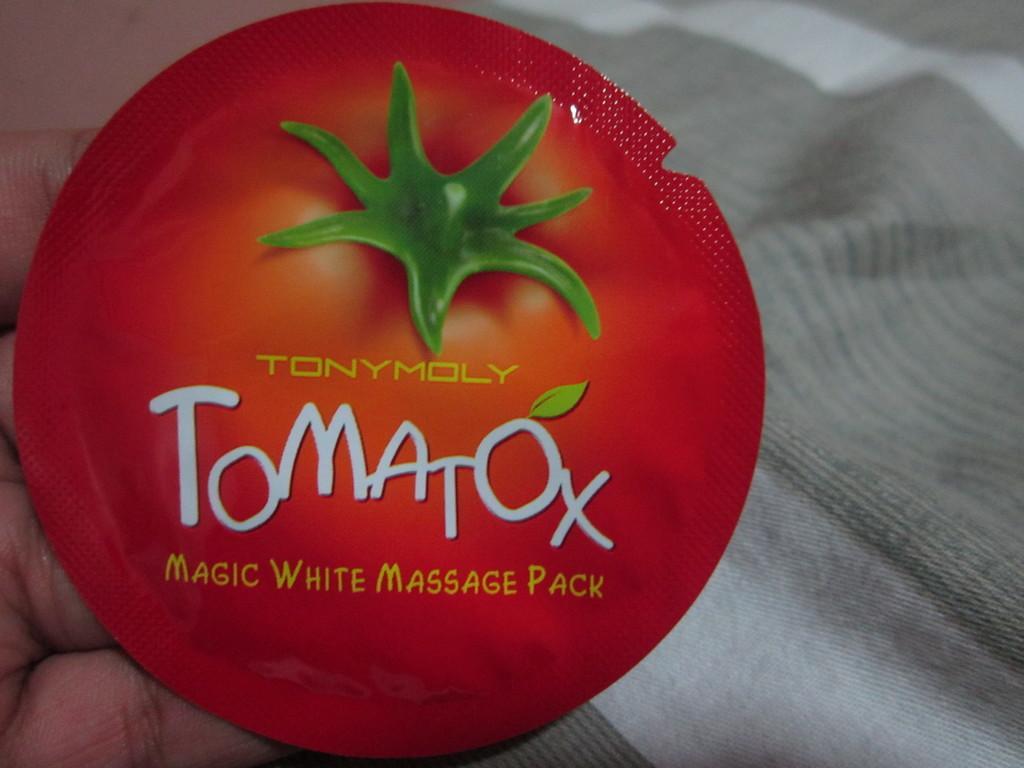Describe this image in one or two sentences. In the picture I can see a person's hand holding a red color object on which we can see some text and it is on the left side of the image. In the background, we can see the white color cloth. 